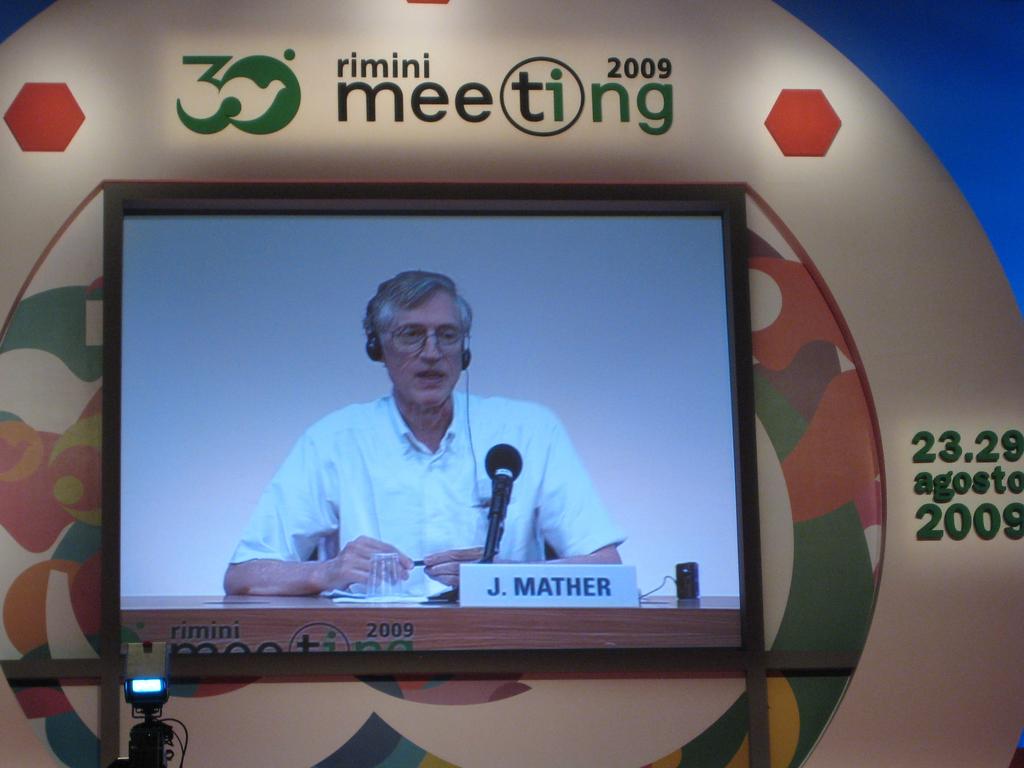What year is posted at the top?
Offer a terse response. 2009. What is the name on the nameplate?
Your answer should be compact. J. mather. 